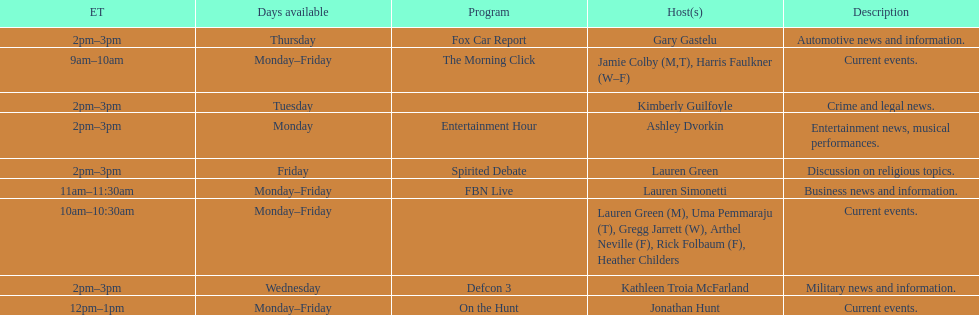How many days is fbn live available each week? 5. 